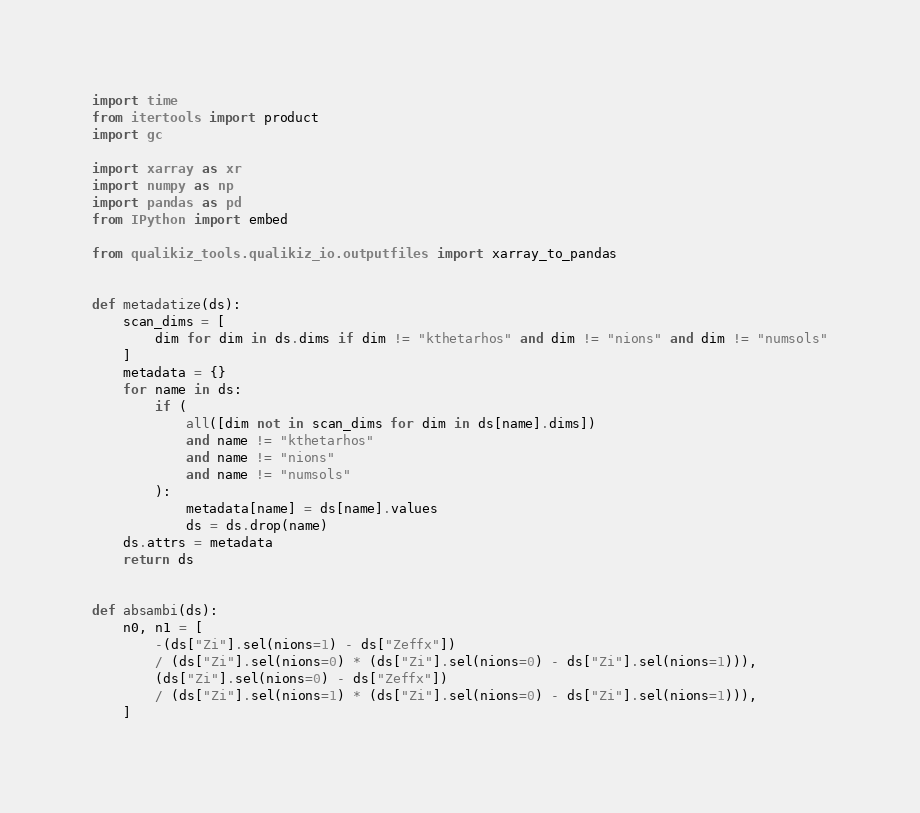Convert code to text. <code><loc_0><loc_0><loc_500><loc_500><_Python_>import time
from itertools import product
import gc

import xarray as xr
import numpy as np
import pandas as pd
from IPython import embed

from qualikiz_tools.qualikiz_io.outputfiles import xarray_to_pandas


def metadatize(ds):
    scan_dims = [
        dim for dim in ds.dims if dim != "kthetarhos" and dim != "nions" and dim != "numsols"
    ]
    metadata = {}
    for name in ds:
        if (
            all([dim not in scan_dims for dim in ds[name].dims])
            and name != "kthetarhos"
            and name != "nions"
            and name != "numsols"
        ):
            metadata[name] = ds[name].values
            ds = ds.drop(name)
    ds.attrs = metadata
    return ds


def absambi(ds):
    n0, n1 = [
        -(ds["Zi"].sel(nions=1) - ds["Zeffx"])
        / (ds["Zi"].sel(nions=0) * (ds["Zi"].sel(nions=0) - ds["Zi"].sel(nions=1))),
        (ds["Zi"].sel(nions=0) - ds["Zeffx"])
        / (ds["Zi"].sel(nions=1) * (ds["Zi"].sel(nions=0) - ds["Zi"].sel(nions=1))),
    ]</code> 